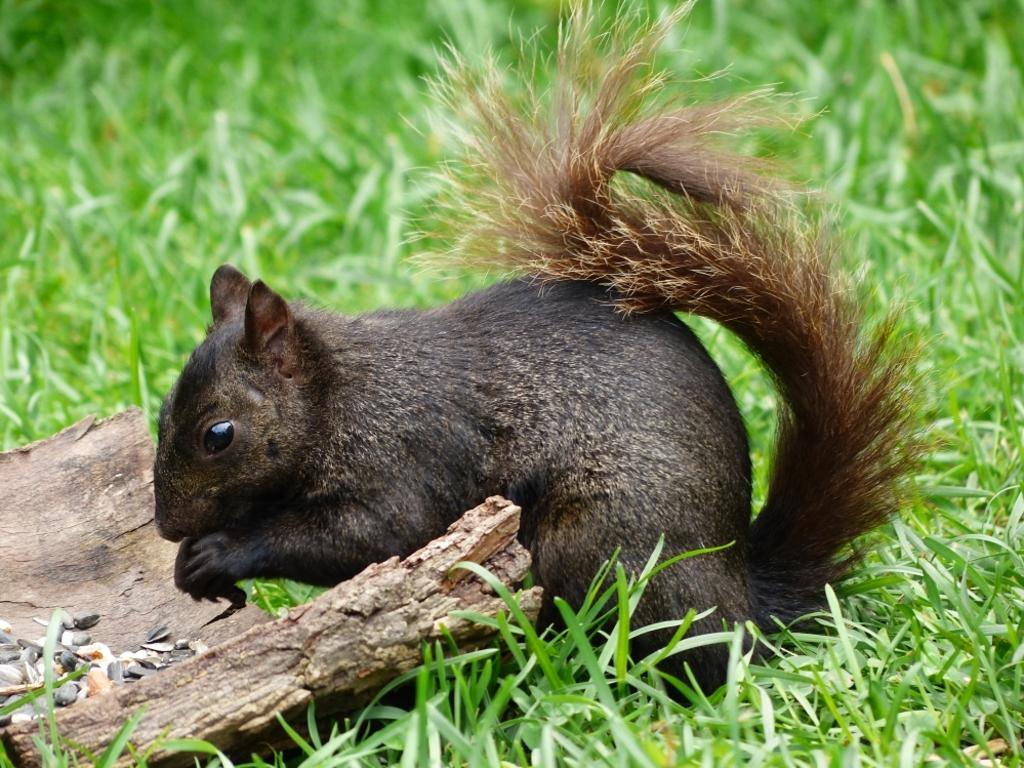What type of animal is in the image? There is a squirrel in the image. Where is the squirrel located? The squirrel is on the surface of the grass. What is in front of the squirrel? There is a trunk of wood in front of the squirrel. What type of feather can be seen on the squirrel's back in the image? There is no feather visible on the squirrel's back in the image, as squirrels have fur, not feathers. 